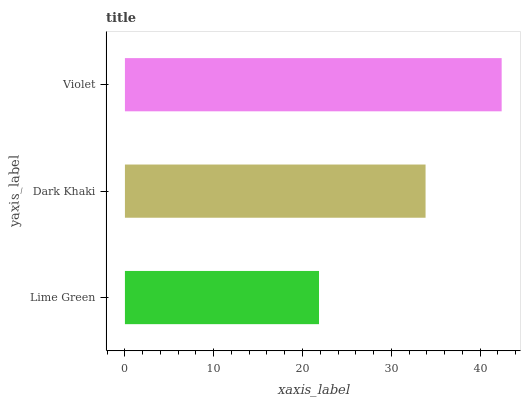Is Lime Green the minimum?
Answer yes or no. Yes. Is Violet the maximum?
Answer yes or no. Yes. Is Dark Khaki the minimum?
Answer yes or no. No. Is Dark Khaki the maximum?
Answer yes or no. No. Is Dark Khaki greater than Lime Green?
Answer yes or no. Yes. Is Lime Green less than Dark Khaki?
Answer yes or no. Yes. Is Lime Green greater than Dark Khaki?
Answer yes or no. No. Is Dark Khaki less than Lime Green?
Answer yes or no. No. Is Dark Khaki the high median?
Answer yes or no. Yes. Is Dark Khaki the low median?
Answer yes or no. Yes. Is Violet the high median?
Answer yes or no. No. Is Lime Green the low median?
Answer yes or no. No. 